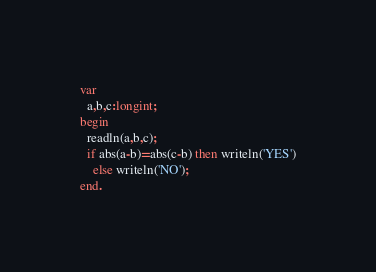<code> <loc_0><loc_0><loc_500><loc_500><_Pascal_>var
  a,b,c:longint;
begin
  readln(a,b,c);
  if abs(a-b)=abs(c-b) then writeln('YES')
    else writeln('NO');
end.</code> 